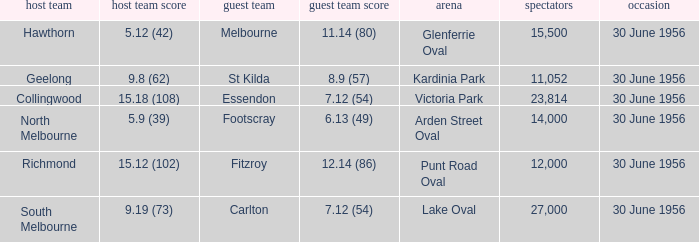What is the home team score when the away team is St Kilda? 9.8 (62). 